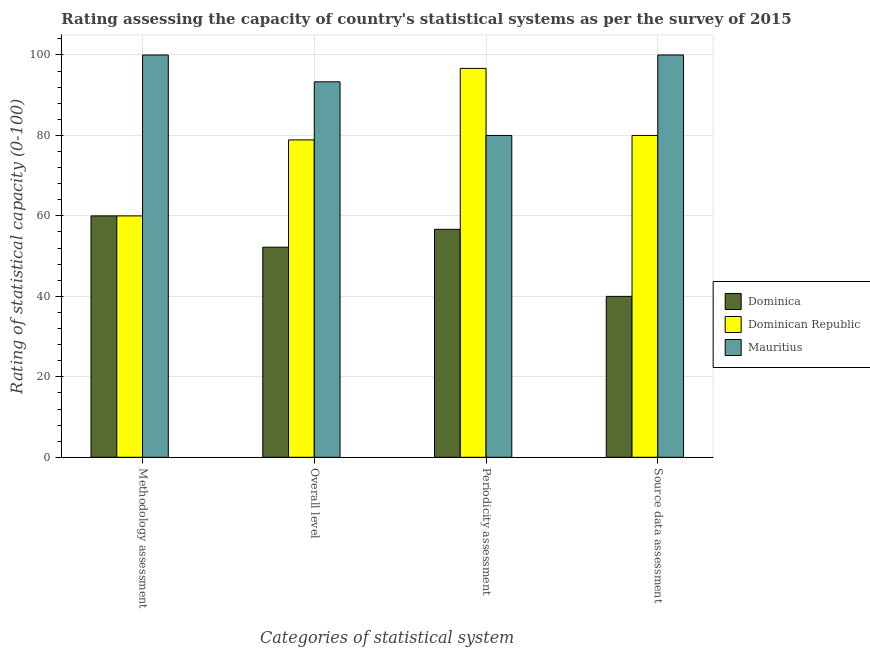How many groups of bars are there?
Give a very brief answer. 4. Are the number of bars per tick equal to the number of legend labels?
Offer a terse response. Yes. How many bars are there on the 4th tick from the right?
Offer a very short reply. 3. What is the label of the 3rd group of bars from the left?
Offer a very short reply. Periodicity assessment. What is the overall level rating in Mauritius?
Keep it short and to the point. 93.33. Across all countries, what is the maximum methodology assessment rating?
Provide a succinct answer. 100. In which country was the methodology assessment rating maximum?
Give a very brief answer. Mauritius. In which country was the source data assessment rating minimum?
Offer a terse response. Dominica. What is the total source data assessment rating in the graph?
Your answer should be very brief. 220. What is the difference between the overall level rating in Mauritius and that in Dominica?
Your response must be concise. 41.11. What is the difference between the methodology assessment rating in Mauritius and the periodicity assessment rating in Dominica?
Provide a short and direct response. 43.33. What is the average methodology assessment rating per country?
Ensure brevity in your answer.  73.33. What is the difference between the methodology assessment rating and periodicity assessment rating in Dominica?
Your answer should be compact. 3.33. In how many countries, is the overall level rating greater than 20 ?
Your answer should be very brief. 3. What is the ratio of the methodology assessment rating in Dominica to that in Dominican Republic?
Offer a very short reply. 1. Is the difference between the overall level rating in Mauritius and Dominican Republic greater than the difference between the methodology assessment rating in Mauritius and Dominican Republic?
Your answer should be very brief. No. What is the difference between the highest and the second highest overall level rating?
Your answer should be very brief. 14.44. What is the difference between the highest and the lowest periodicity assessment rating?
Give a very brief answer. 40. Is it the case that in every country, the sum of the periodicity assessment rating and source data assessment rating is greater than the sum of overall level rating and methodology assessment rating?
Your answer should be very brief. No. What does the 2nd bar from the left in Periodicity assessment represents?
Your answer should be compact. Dominican Republic. What does the 2nd bar from the right in Source data assessment represents?
Offer a terse response. Dominican Republic. Is it the case that in every country, the sum of the methodology assessment rating and overall level rating is greater than the periodicity assessment rating?
Your answer should be very brief. Yes. How many bars are there?
Provide a succinct answer. 12. Are all the bars in the graph horizontal?
Provide a short and direct response. No. What is the difference between two consecutive major ticks on the Y-axis?
Provide a short and direct response. 20. Does the graph contain any zero values?
Give a very brief answer. No. Where does the legend appear in the graph?
Your response must be concise. Center right. How many legend labels are there?
Your answer should be compact. 3. What is the title of the graph?
Keep it short and to the point. Rating assessing the capacity of country's statistical systems as per the survey of 2015 . What is the label or title of the X-axis?
Keep it short and to the point. Categories of statistical system. What is the label or title of the Y-axis?
Provide a short and direct response. Rating of statistical capacity (0-100). What is the Rating of statistical capacity (0-100) in Dominican Republic in Methodology assessment?
Ensure brevity in your answer.  60. What is the Rating of statistical capacity (0-100) in Dominica in Overall level?
Provide a succinct answer. 52.22. What is the Rating of statistical capacity (0-100) of Dominican Republic in Overall level?
Your answer should be compact. 78.89. What is the Rating of statistical capacity (0-100) in Mauritius in Overall level?
Give a very brief answer. 93.33. What is the Rating of statistical capacity (0-100) in Dominica in Periodicity assessment?
Keep it short and to the point. 56.67. What is the Rating of statistical capacity (0-100) in Dominican Republic in Periodicity assessment?
Your answer should be very brief. 96.67. What is the Rating of statistical capacity (0-100) of Mauritius in Periodicity assessment?
Offer a very short reply. 80. What is the Rating of statistical capacity (0-100) in Dominica in Source data assessment?
Give a very brief answer. 40. Across all Categories of statistical system, what is the maximum Rating of statistical capacity (0-100) in Dominican Republic?
Give a very brief answer. 96.67. Across all Categories of statistical system, what is the maximum Rating of statistical capacity (0-100) of Mauritius?
Give a very brief answer. 100. Across all Categories of statistical system, what is the minimum Rating of statistical capacity (0-100) in Dominican Republic?
Make the answer very short. 60. Across all Categories of statistical system, what is the minimum Rating of statistical capacity (0-100) in Mauritius?
Ensure brevity in your answer.  80. What is the total Rating of statistical capacity (0-100) in Dominica in the graph?
Your response must be concise. 208.89. What is the total Rating of statistical capacity (0-100) of Dominican Republic in the graph?
Your answer should be compact. 315.56. What is the total Rating of statistical capacity (0-100) in Mauritius in the graph?
Your answer should be compact. 373.33. What is the difference between the Rating of statistical capacity (0-100) in Dominica in Methodology assessment and that in Overall level?
Provide a short and direct response. 7.78. What is the difference between the Rating of statistical capacity (0-100) in Dominican Republic in Methodology assessment and that in Overall level?
Your answer should be compact. -18.89. What is the difference between the Rating of statistical capacity (0-100) of Mauritius in Methodology assessment and that in Overall level?
Provide a short and direct response. 6.67. What is the difference between the Rating of statistical capacity (0-100) of Dominica in Methodology assessment and that in Periodicity assessment?
Provide a succinct answer. 3.33. What is the difference between the Rating of statistical capacity (0-100) in Dominican Republic in Methodology assessment and that in Periodicity assessment?
Give a very brief answer. -36.67. What is the difference between the Rating of statistical capacity (0-100) of Mauritius in Methodology assessment and that in Periodicity assessment?
Keep it short and to the point. 20. What is the difference between the Rating of statistical capacity (0-100) of Dominican Republic in Methodology assessment and that in Source data assessment?
Provide a short and direct response. -20. What is the difference between the Rating of statistical capacity (0-100) of Mauritius in Methodology assessment and that in Source data assessment?
Provide a succinct answer. 0. What is the difference between the Rating of statistical capacity (0-100) in Dominica in Overall level and that in Periodicity assessment?
Offer a terse response. -4.44. What is the difference between the Rating of statistical capacity (0-100) in Dominican Republic in Overall level and that in Periodicity assessment?
Provide a succinct answer. -17.78. What is the difference between the Rating of statistical capacity (0-100) of Mauritius in Overall level and that in Periodicity assessment?
Ensure brevity in your answer.  13.33. What is the difference between the Rating of statistical capacity (0-100) of Dominica in Overall level and that in Source data assessment?
Keep it short and to the point. 12.22. What is the difference between the Rating of statistical capacity (0-100) of Dominican Republic in Overall level and that in Source data assessment?
Give a very brief answer. -1.11. What is the difference between the Rating of statistical capacity (0-100) of Mauritius in Overall level and that in Source data assessment?
Provide a succinct answer. -6.67. What is the difference between the Rating of statistical capacity (0-100) in Dominica in Periodicity assessment and that in Source data assessment?
Offer a terse response. 16.67. What is the difference between the Rating of statistical capacity (0-100) in Dominican Republic in Periodicity assessment and that in Source data assessment?
Offer a terse response. 16.67. What is the difference between the Rating of statistical capacity (0-100) in Mauritius in Periodicity assessment and that in Source data assessment?
Provide a short and direct response. -20. What is the difference between the Rating of statistical capacity (0-100) of Dominica in Methodology assessment and the Rating of statistical capacity (0-100) of Dominican Republic in Overall level?
Your answer should be compact. -18.89. What is the difference between the Rating of statistical capacity (0-100) in Dominica in Methodology assessment and the Rating of statistical capacity (0-100) in Mauritius in Overall level?
Keep it short and to the point. -33.33. What is the difference between the Rating of statistical capacity (0-100) in Dominican Republic in Methodology assessment and the Rating of statistical capacity (0-100) in Mauritius in Overall level?
Offer a terse response. -33.33. What is the difference between the Rating of statistical capacity (0-100) in Dominica in Methodology assessment and the Rating of statistical capacity (0-100) in Dominican Republic in Periodicity assessment?
Provide a short and direct response. -36.67. What is the difference between the Rating of statistical capacity (0-100) in Dominica in Methodology assessment and the Rating of statistical capacity (0-100) in Mauritius in Periodicity assessment?
Give a very brief answer. -20. What is the difference between the Rating of statistical capacity (0-100) of Dominican Republic in Methodology assessment and the Rating of statistical capacity (0-100) of Mauritius in Periodicity assessment?
Offer a terse response. -20. What is the difference between the Rating of statistical capacity (0-100) of Dominica in Methodology assessment and the Rating of statistical capacity (0-100) of Dominican Republic in Source data assessment?
Provide a short and direct response. -20. What is the difference between the Rating of statistical capacity (0-100) in Dominica in Methodology assessment and the Rating of statistical capacity (0-100) in Mauritius in Source data assessment?
Offer a very short reply. -40. What is the difference between the Rating of statistical capacity (0-100) of Dominica in Overall level and the Rating of statistical capacity (0-100) of Dominican Republic in Periodicity assessment?
Ensure brevity in your answer.  -44.44. What is the difference between the Rating of statistical capacity (0-100) of Dominica in Overall level and the Rating of statistical capacity (0-100) of Mauritius in Periodicity assessment?
Give a very brief answer. -27.78. What is the difference between the Rating of statistical capacity (0-100) in Dominican Republic in Overall level and the Rating of statistical capacity (0-100) in Mauritius in Periodicity assessment?
Your answer should be very brief. -1.11. What is the difference between the Rating of statistical capacity (0-100) in Dominica in Overall level and the Rating of statistical capacity (0-100) in Dominican Republic in Source data assessment?
Your answer should be compact. -27.78. What is the difference between the Rating of statistical capacity (0-100) of Dominica in Overall level and the Rating of statistical capacity (0-100) of Mauritius in Source data assessment?
Provide a short and direct response. -47.78. What is the difference between the Rating of statistical capacity (0-100) in Dominican Republic in Overall level and the Rating of statistical capacity (0-100) in Mauritius in Source data assessment?
Your response must be concise. -21.11. What is the difference between the Rating of statistical capacity (0-100) in Dominica in Periodicity assessment and the Rating of statistical capacity (0-100) in Dominican Republic in Source data assessment?
Ensure brevity in your answer.  -23.33. What is the difference between the Rating of statistical capacity (0-100) in Dominica in Periodicity assessment and the Rating of statistical capacity (0-100) in Mauritius in Source data assessment?
Give a very brief answer. -43.33. What is the difference between the Rating of statistical capacity (0-100) in Dominican Republic in Periodicity assessment and the Rating of statistical capacity (0-100) in Mauritius in Source data assessment?
Your response must be concise. -3.33. What is the average Rating of statistical capacity (0-100) in Dominica per Categories of statistical system?
Your response must be concise. 52.22. What is the average Rating of statistical capacity (0-100) of Dominican Republic per Categories of statistical system?
Make the answer very short. 78.89. What is the average Rating of statistical capacity (0-100) in Mauritius per Categories of statistical system?
Offer a very short reply. 93.33. What is the difference between the Rating of statistical capacity (0-100) of Dominica and Rating of statistical capacity (0-100) of Mauritius in Methodology assessment?
Your response must be concise. -40. What is the difference between the Rating of statistical capacity (0-100) of Dominican Republic and Rating of statistical capacity (0-100) of Mauritius in Methodology assessment?
Offer a very short reply. -40. What is the difference between the Rating of statistical capacity (0-100) in Dominica and Rating of statistical capacity (0-100) in Dominican Republic in Overall level?
Make the answer very short. -26.67. What is the difference between the Rating of statistical capacity (0-100) of Dominica and Rating of statistical capacity (0-100) of Mauritius in Overall level?
Your answer should be compact. -41.11. What is the difference between the Rating of statistical capacity (0-100) of Dominican Republic and Rating of statistical capacity (0-100) of Mauritius in Overall level?
Your answer should be very brief. -14.44. What is the difference between the Rating of statistical capacity (0-100) in Dominica and Rating of statistical capacity (0-100) in Mauritius in Periodicity assessment?
Your answer should be very brief. -23.33. What is the difference between the Rating of statistical capacity (0-100) in Dominican Republic and Rating of statistical capacity (0-100) in Mauritius in Periodicity assessment?
Make the answer very short. 16.67. What is the difference between the Rating of statistical capacity (0-100) in Dominica and Rating of statistical capacity (0-100) in Dominican Republic in Source data assessment?
Your answer should be very brief. -40. What is the difference between the Rating of statistical capacity (0-100) of Dominica and Rating of statistical capacity (0-100) of Mauritius in Source data assessment?
Your answer should be very brief. -60. What is the ratio of the Rating of statistical capacity (0-100) of Dominica in Methodology assessment to that in Overall level?
Provide a succinct answer. 1.15. What is the ratio of the Rating of statistical capacity (0-100) in Dominican Republic in Methodology assessment to that in Overall level?
Give a very brief answer. 0.76. What is the ratio of the Rating of statistical capacity (0-100) in Mauritius in Methodology assessment to that in Overall level?
Your answer should be compact. 1.07. What is the ratio of the Rating of statistical capacity (0-100) of Dominica in Methodology assessment to that in Periodicity assessment?
Your answer should be very brief. 1.06. What is the ratio of the Rating of statistical capacity (0-100) of Dominican Republic in Methodology assessment to that in Periodicity assessment?
Ensure brevity in your answer.  0.62. What is the ratio of the Rating of statistical capacity (0-100) of Mauritius in Methodology assessment to that in Periodicity assessment?
Provide a short and direct response. 1.25. What is the ratio of the Rating of statistical capacity (0-100) of Dominica in Methodology assessment to that in Source data assessment?
Keep it short and to the point. 1.5. What is the ratio of the Rating of statistical capacity (0-100) in Dominica in Overall level to that in Periodicity assessment?
Make the answer very short. 0.92. What is the ratio of the Rating of statistical capacity (0-100) in Dominican Republic in Overall level to that in Periodicity assessment?
Your response must be concise. 0.82. What is the ratio of the Rating of statistical capacity (0-100) in Mauritius in Overall level to that in Periodicity assessment?
Your answer should be compact. 1.17. What is the ratio of the Rating of statistical capacity (0-100) of Dominica in Overall level to that in Source data assessment?
Keep it short and to the point. 1.31. What is the ratio of the Rating of statistical capacity (0-100) of Dominican Republic in Overall level to that in Source data assessment?
Give a very brief answer. 0.99. What is the ratio of the Rating of statistical capacity (0-100) of Mauritius in Overall level to that in Source data assessment?
Make the answer very short. 0.93. What is the ratio of the Rating of statistical capacity (0-100) of Dominica in Periodicity assessment to that in Source data assessment?
Offer a terse response. 1.42. What is the ratio of the Rating of statistical capacity (0-100) in Dominican Republic in Periodicity assessment to that in Source data assessment?
Ensure brevity in your answer.  1.21. What is the difference between the highest and the second highest Rating of statistical capacity (0-100) in Dominica?
Your answer should be very brief. 3.33. What is the difference between the highest and the second highest Rating of statistical capacity (0-100) of Dominican Republic?
Provide a succinct answer. 16.67. What is the difference between the highest and the lowest Rating of statistical capacity (0-100) in Dominican Republic?
Your answer should be very brief. 36.67. What is the difference between the highest and the lowest Rating of statistical capacity (0-100) of Mauritius?
Offer a terse response. 20. 